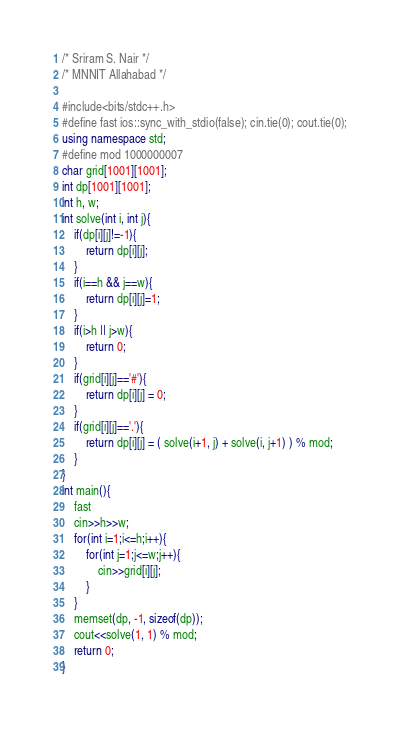<code> <loc_0><loc_0><loc_500><loc_500><_C++_>/* Sriram S. Nair */
/* MNNIT Allahabad */

#include<bits/stdc++.h>
#define fast ios::sync_with_stdio(false); cin.tie(0); cout.tie(0);
using namespace std;
#define mod 1000000007
char grid[1001][1001];
int dp[1001][1001];
int h, w;
int solve(int i, int j){
	if(dp[i][j]!=-1){
		return dp[i][j];
	}
	if(i==h && j==w){
		return dp[i][j]=1;
	}
	if(i>h || j>w){
		return 0;
	}
	if(grid[i][j]=='#'){
		return dp[i][j] = 0;
	}
	if(grid[i][j]=='.'){
		return dp[i][j] = ( solve(i+1, j) + solve(i, j+1) ) % mod;
	}
}
int main(){
	fast
	cin>>h>>w;
	for(int i=1;i<=h;i++){
		for(int j=1;j<=w;j++){
			cin>>grid[i][j];
		}
	}
	memset(dp, -1, sizeof(dp));
	cout<<solve(1, 1) % mod;
	return 0;
}</code> 